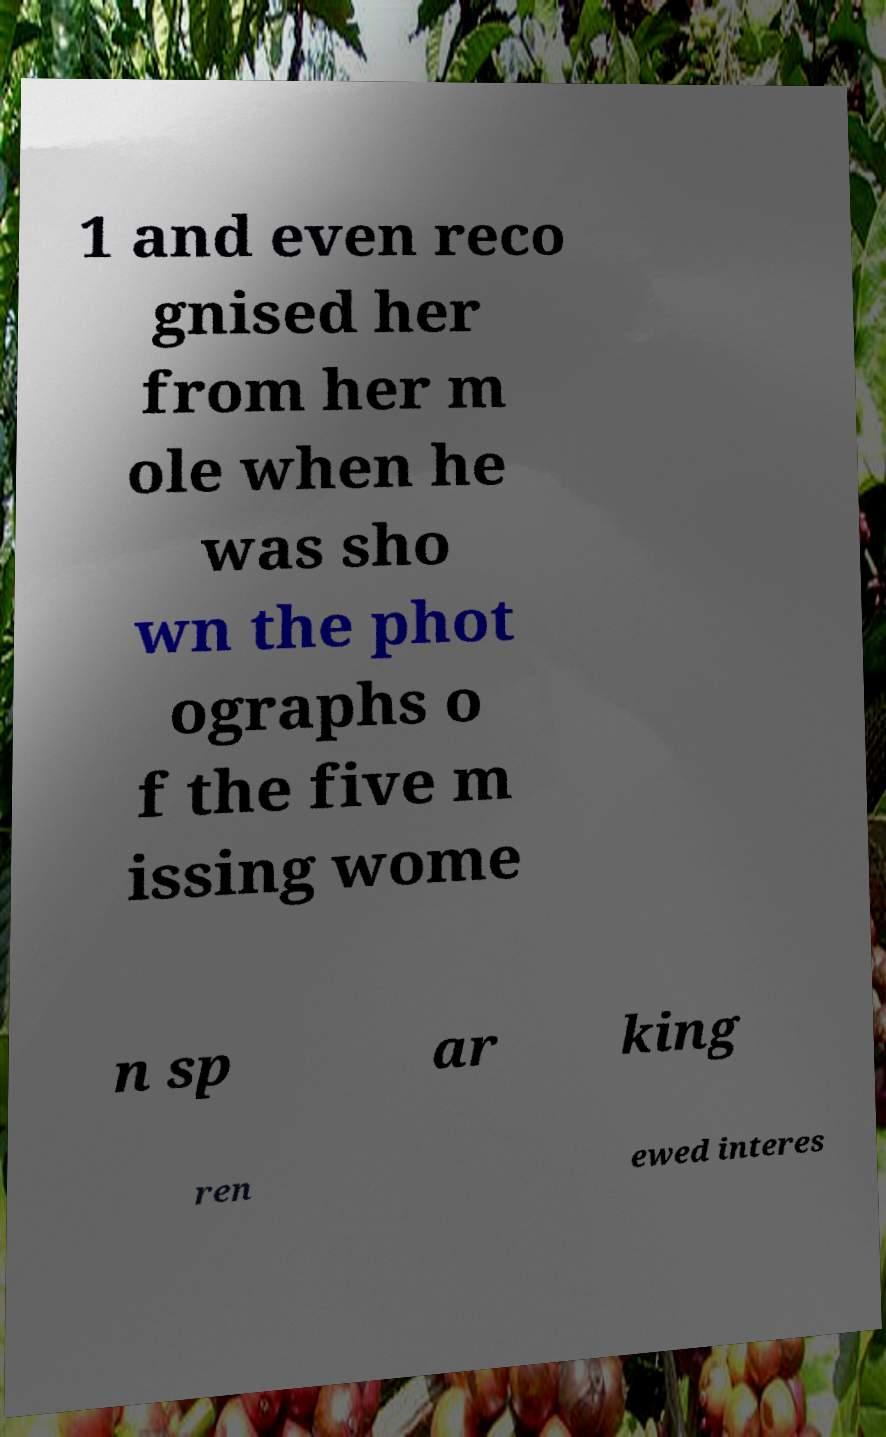Can you read and provide the text displayed in the image?This photo seems to have some interesting text. Can you extract and type it out for me? 1 and even reco gnised her from her m ole when he was sho wn the phot ographs o f the five m issing wome n sp ar king ren ewed interes 